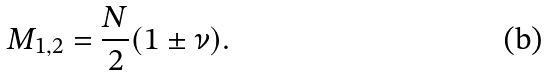Convert formula to latex. <formula><loc_0><loc_0><loc_500><loc_500>M _ { 1 , 2 } = \frac { N } { 2 } ( 1 \pm \nu ) .</formula> 